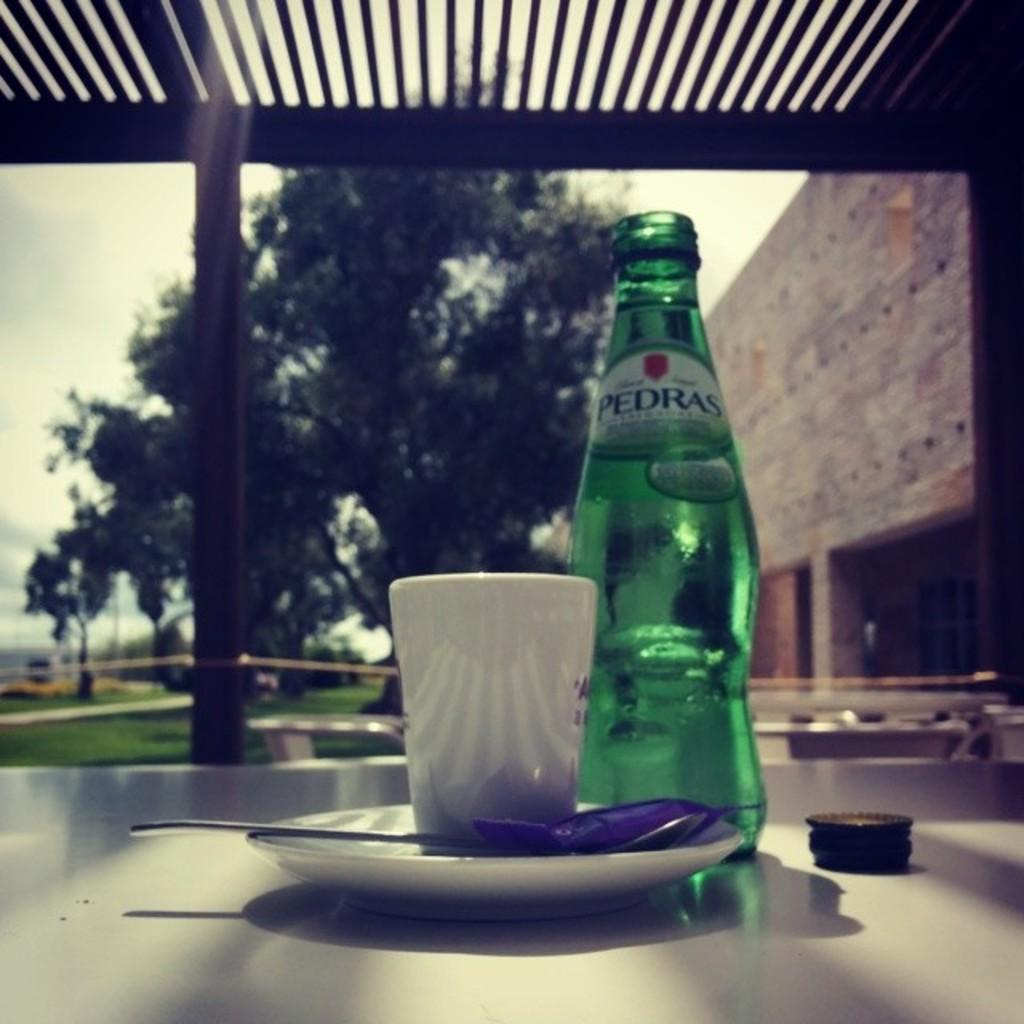What piece of furniture is present in the image? There is a table in the image. What items are on the table? The table has a drink bottle and a cup on it. What can be seen in the background of the image? There is a building and trees in the background of the image. What type of joke is being told by the building in the image? There is no joke being told by the building in the image; it is a stationary structure in the background. 